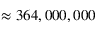<formula> <loc_0><loc_0><loc_500><loc_500>\approx 3 6 4 , 0 0 0 , 0 0 0</formula> 